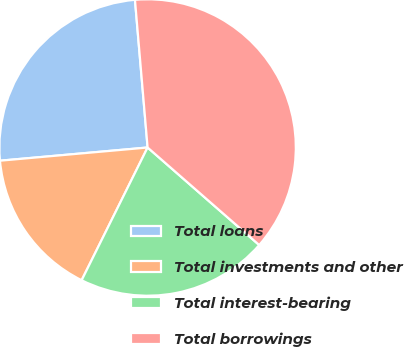Convert chart to OTSL. <chart><loc_0><loc_0><loc_500><loc_500><pie_chart><fcel>Total loans<fcel>Total investments and other<fcel>Total interest-bearing<fcel>Total borrowings<nl><fcel>25.06%<fcel>16.24%<fcel>20.91%<fcel>37.79%<nl></chart> 